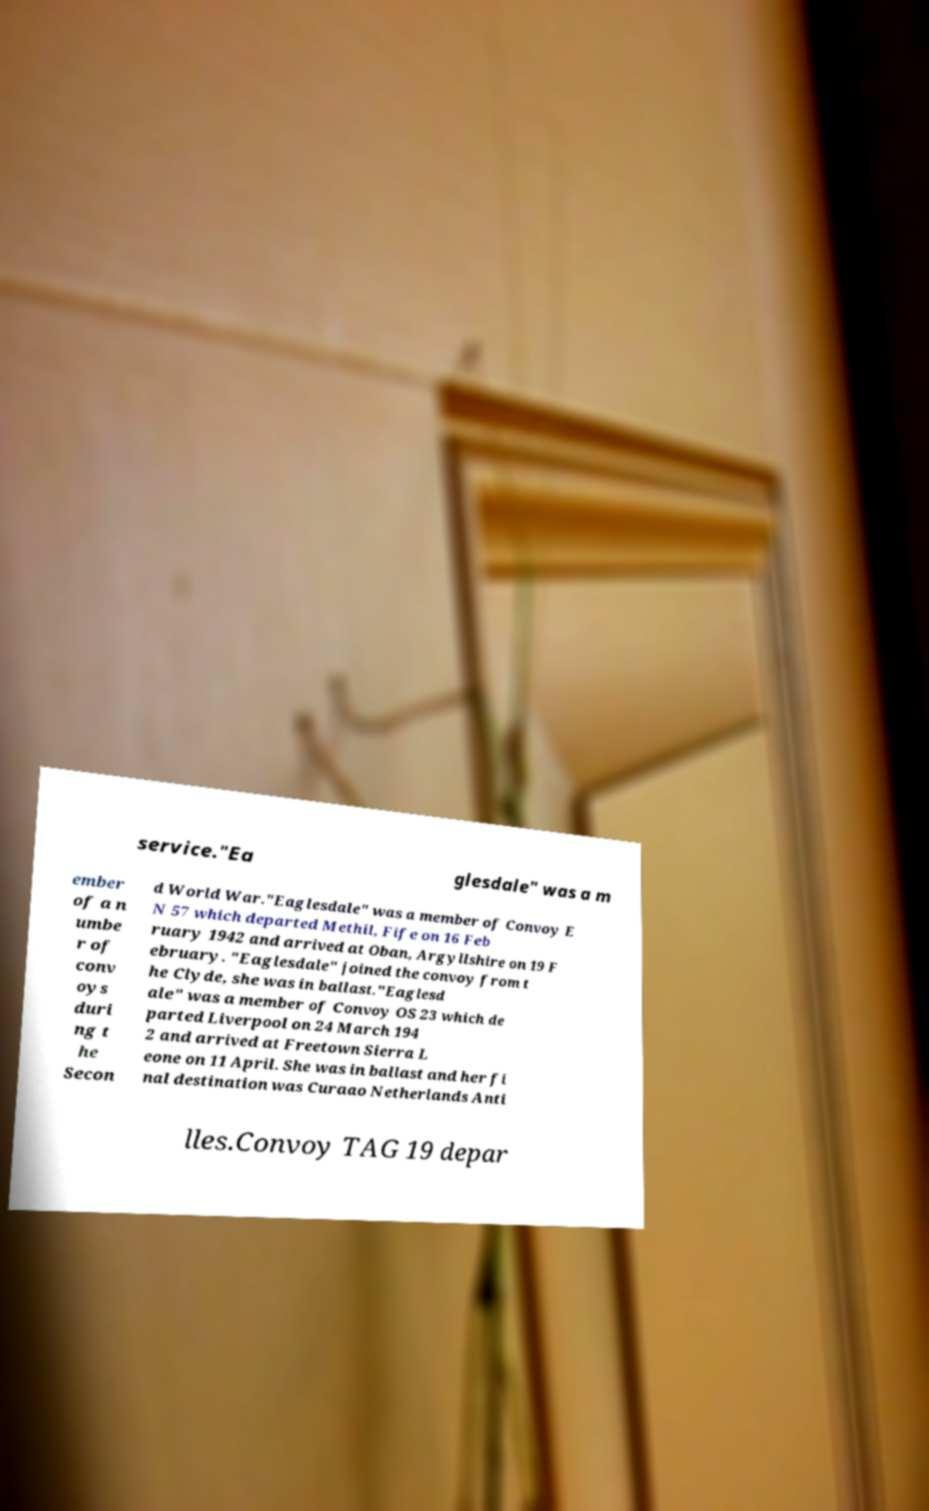Could you extract and type out the text from this image? service."Ea glesdale" was a m ember of a n umbe r of conv oys duri ng t he Secon d World War."Eaglesdale" was a member of Convoy E N 57 which departed Methil, Fife on 16 Feb ruary 1942 and arrived at Oban, Argyllshire on 19 F ebruary. "Eaglesdale" joined the convoy from t he Clyde, she was in ballast."Eaglesd ale" was a member of Convoy OS 23 which de parted Liverpool on 24 March 194 2 and arrived at Freetown Sierra L eone on 11 April. She was in ballast and her fi nal destination was Curaao Netherlands Anti lles.Convoy TAG 19 depar 